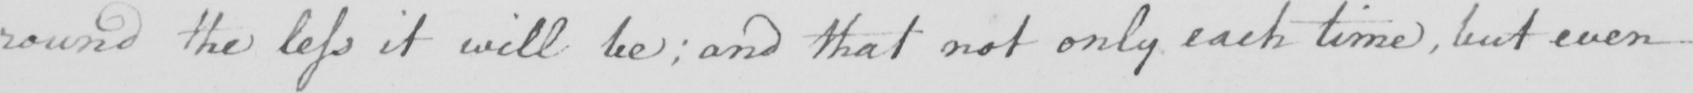What does this handwritten line say? round the less it will be ; and that not only each time , but even 